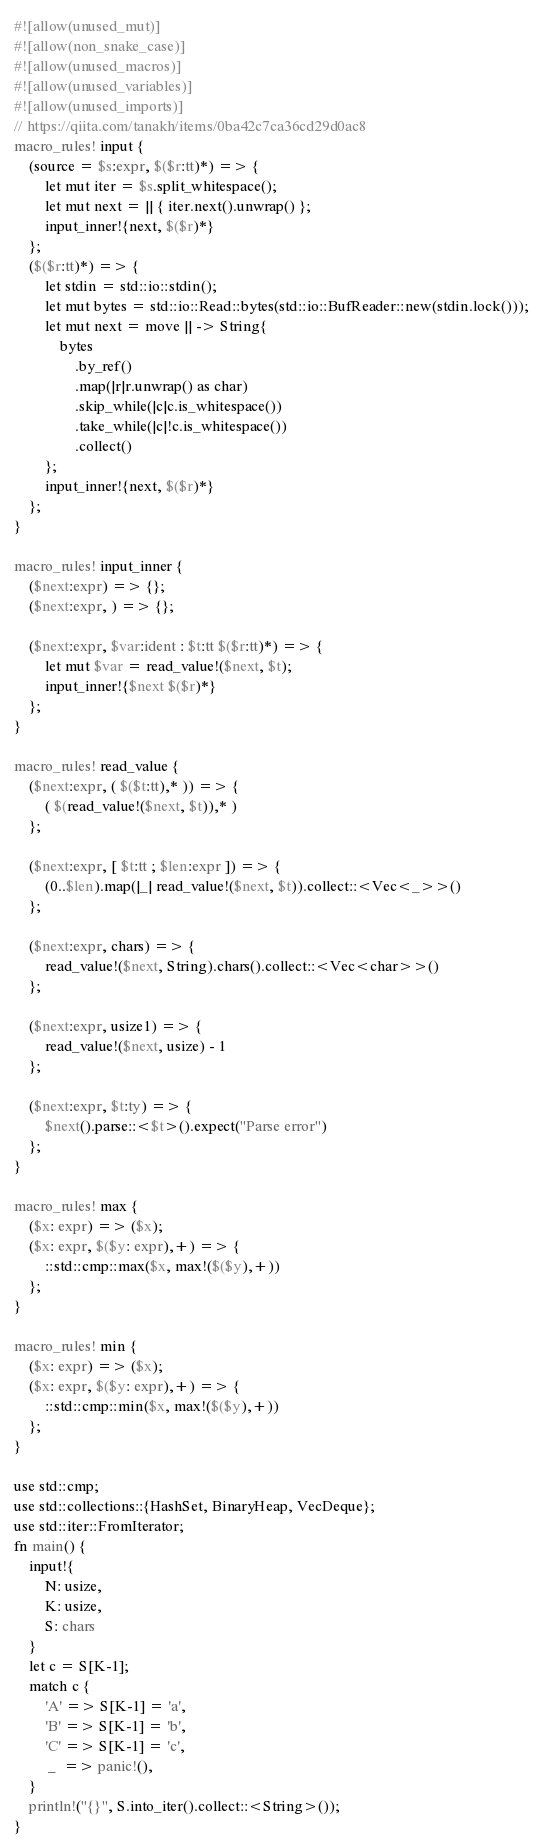<code> <loc_0><loc_0><loc_500><loc_500><_Rust_>#![allow(unused_mut)]
#![allow(non_snake_case)]
#![allow(unused_macros)]
#![allow(unused_variables)]
#![allow(unused_imports)]
// https://qiita.com/tanakh/items/0ba42c7ca36cd29d0ac8
macro_rules! input {
    (source = $s:expr, $($r:tt)*) => {
        let mut iter = $s.split_whitespace();
        let mut next = || { iter.next().unwrap() };
        input_inner!{next, $($r)*}
    };
    ($($r:tt)*) => {
        let stdin = std::io::stdin();
        let mut bytes = std::io::Read::bytes(std::io::BufReader::new(stdin.lock()));
        let mut next = move || -> String{
            bytes
                .by_ref()
                .map(|r|r.unwrap() as char)
                .skip_while(|c|c.is_whitespace())
                .take_while(|c|!c.is_whitespace())
                .collect()
        };
        input_inner!{next, $($r)*}
    };
}

macro_rules! input_inner {
    ($next:expr) => {};
    ($next:expr, ) => {};

    ($next:expr, $var:ident : $t:tt $($r:tt)*) => {
        let mut $var = read_value!($next, $t);
        input_inner!{$next $($r)*}
    };
}

macro_rules! read_value {
    ($next:expr, ( $($t:tt),* )) => {
        ( $(read_value!($next, $t)),* )
    };

    ($next:expr, [ $t:tt ; $len:expr ]) => {
        (0..$len).map(|_| read_value!($next, $t)).collect::<Vec<_>>()
    };

    ($next:expr, chars) => {
        read_value!($next, String).chars().collect::<Vec<char>>()
    };

    ($next:expr, usize1) => {
        read_value!($next, usize) - 1
    };

    ($next:expr, $t:ty) => {
        $next().parse::<$t>().expect("Parse error")
    };
}

macro_rules! max {
    ($x: expr) => ($x);
    ($x: expr, $($y: expr),+) => {
        ::std::cmp::max($x, max!($($y),+))
    };
}

macro_rules! min {
    ($x: expr) => ($x);
    ($x: expr, $($y: expr),+) => {
        ::std::cmp::min($x, max!($($y),+))
    };
}

use std::cmp;
use std::collections::{HashSet, BinaryHeap, VecDeque};
use std::iter::FromIterator;
fn main() {
    input!{
        N: usize,
        K: usize,
        S: chars
    }
    let c = S[K-1];
    match c {
        'A' => S[K-1] = 'a',
        'B' => S[K-1] = 'b',
        'C' => S[K-1] = 'c',
         _  => panic!(),
    }
    println!("{}", S.into_iter().collect::<String>());
}</code> 